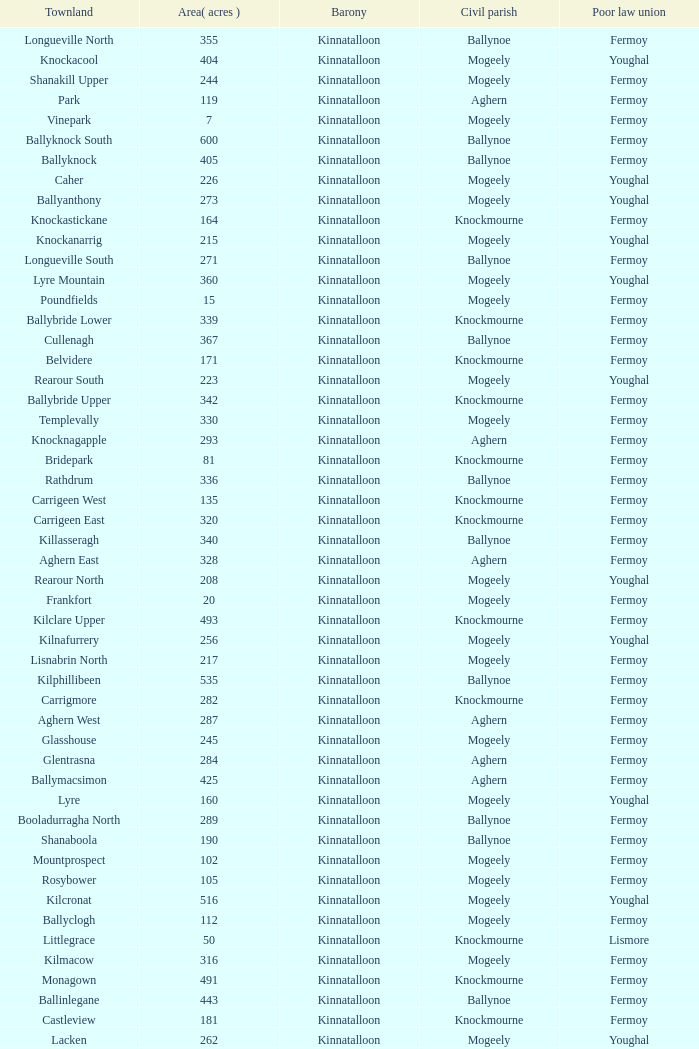Name  the townland for fermoy and ballynoe Ballinlegane, Ballinscurloge, Ballyknock, Ballyknock North, Ballyknock South, Ballymonteen, Ballynattin, Ballynoe, Booladurragha North, Booladurragha South, Cullenagh, Garraneribbeen, Glenreagh, Glentane, Killasseragh, Kilphillibeen, Knockakeo, Longueville North, Longueville South, Rathdrum, Shanaboola. 